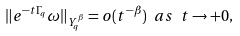<formula> <loc_0><loc_0><loc_500><loc_500>\| e ^ { - t \Gamma _ { q } } \omega \| _ { Y ^ { \beta } _ { q } } = o ( t ^ { - \beta } ) \ a s \ t \rightarrow + 0 ,</formula> 